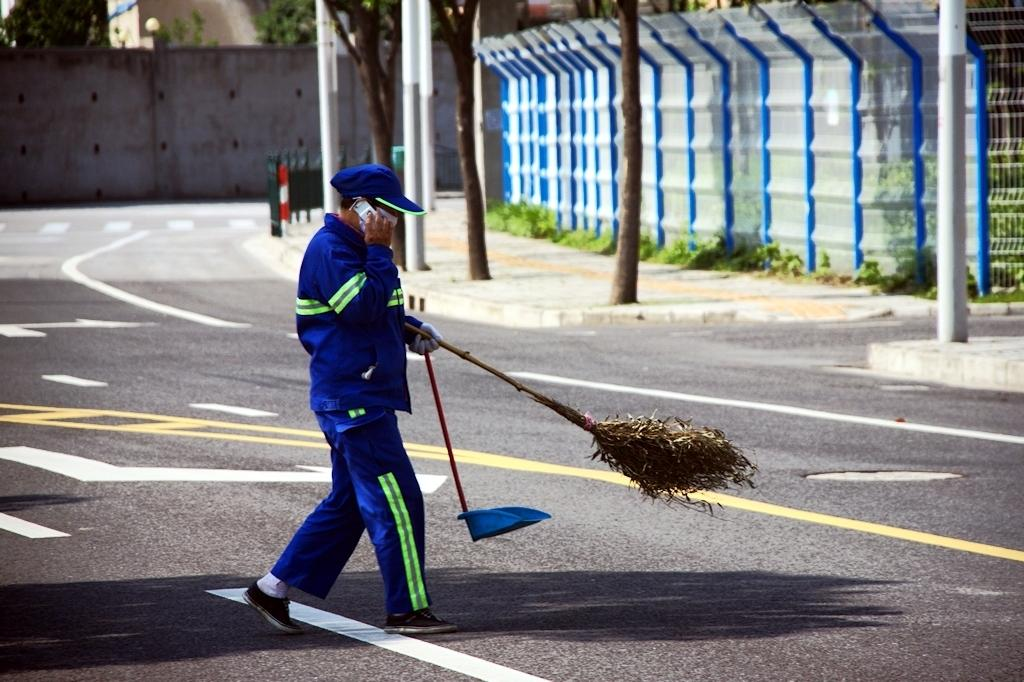What is the man in the image doing? The man is holding a broomstick and talking on a mobile phone. What is the setting of the image? This is a road. What can be seen in the background of the image? There is a wall, a fence, plants, and trees in the background of the image. Where are the chickens running around in the image? There are no chickens present in the image. What type of net can be seen in the image? There is no net visible in the image. 